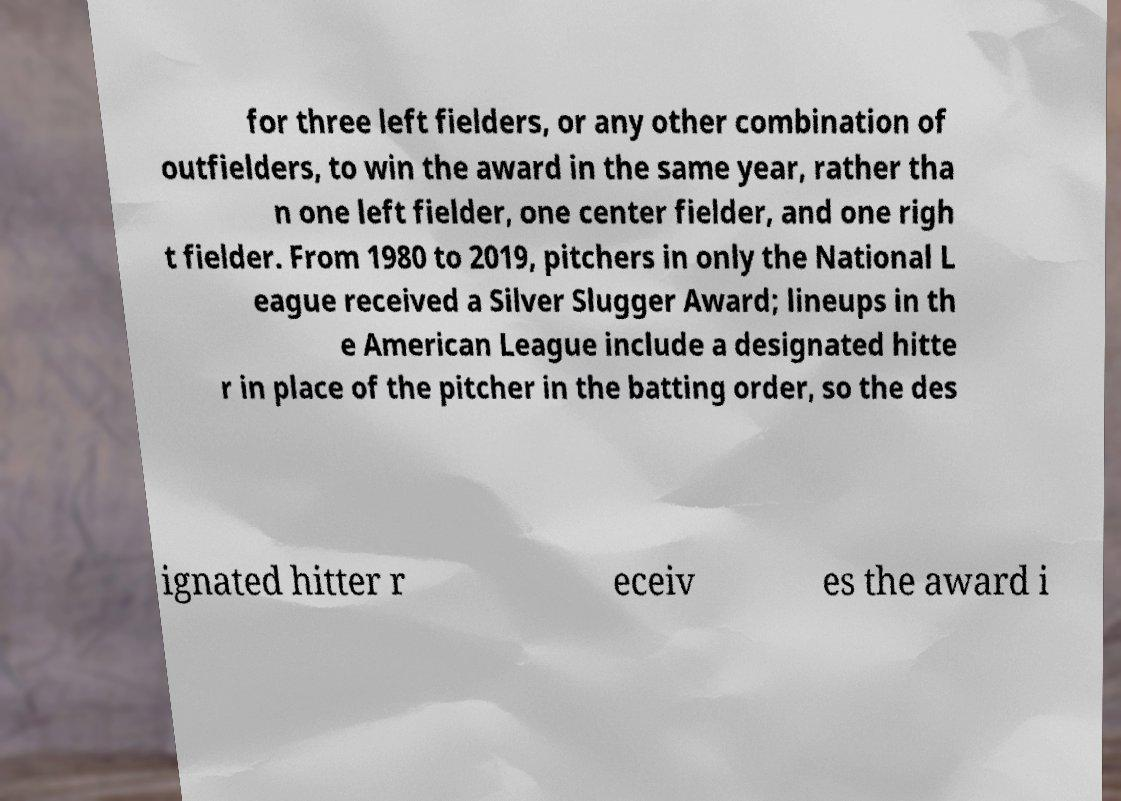Could you assist in decoding the text presented in this image and type it out clearly? for three left fielders, or any other combination of outfielders, to win the award in the same year, rather tha n one left fielder, one center fielder, and one righ t fielder. From 1980 to 2019, pitchers in only the National L eague received a Silver Slugger Award; lineups in th e American League include a designated hitte r in place of the pitcher in the batting order, so the des ignated hitter r eceiv es the award i 